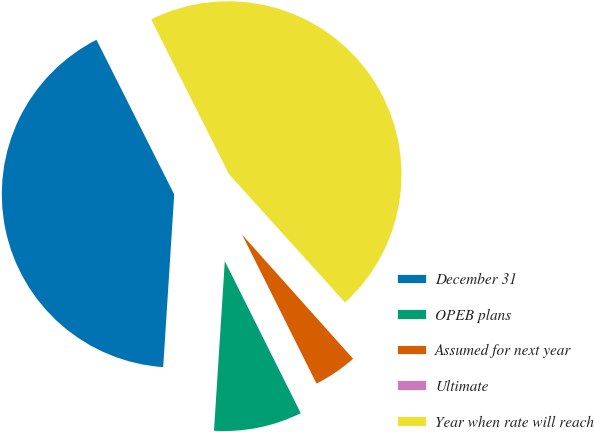Convert chart to OTSL. <chart><loc_0><loc_0><loc_500><loc_500><pie_chart><fcel>December 31<fcel>OPEB plans<fcel>Assumed for next year<fcel>Ultimate<fcel>Year when rate will reach<nl><fcel>41.57%<fcel>8.39%<fcel>4.24%<fcel>0.08%<fcel>45.72%<nl></chart> 